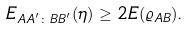<formula> <loc_0><loc_0><loc_500><loc_500>E _ { A A ^ { ^ { \prime } } \colon B B ^ { ^ { \prime } } } ( \eta ) \geq 2 E ( \varrho _ { A B } ) .</formula> 